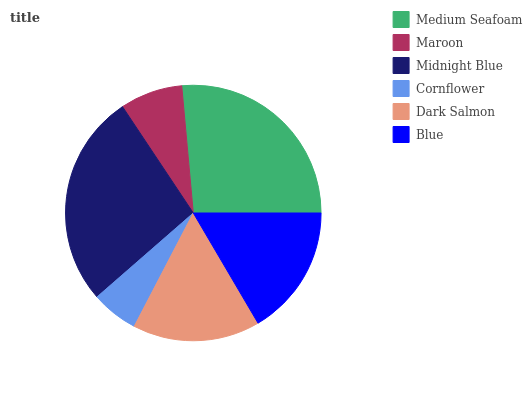Is Cornflower the minimum?
Answer yes or no. Yes. Is Midnight Blue the maximum?
Answer yes or no. Yes. Is Maroon the minimum?
Answer yes or no. No. Is Maroon the maximum?
Answer yes or no. No. Is Medium Seafoam greater than Maroon?
Answer yes or no. Yes. Is Maroon less than Medium Seafoam?
Answer yes or no. Yes. Is Maroon greater than Medium Seafoam?
Answer yes or no. No. Is Medium Seafoam less than Maroon?
Answer yes or no. No. Is Blue the high median?
Answer yes or no. Yes. Is Dark Salmon the low median?
Answer yes or no. Yes. Is Dark Salmon the high median?
Answer yes or no. No. Is Cornflower the low median?
Answer yes or no. No. 